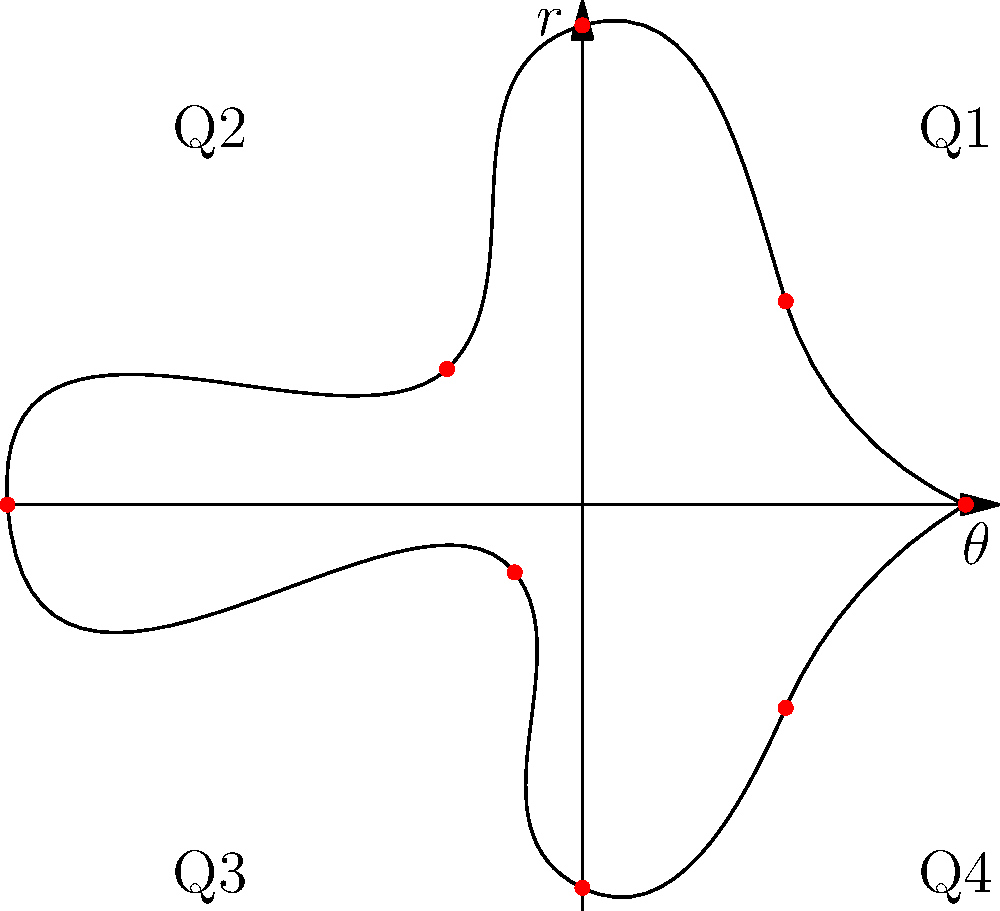As a business school student, you're analyzing quarterly economic trends for Brown Industries. The polar graph represents the company's revenue over two years, where the radius ($r$) indicates revenue in millions, and the angle ($\theta$) represents quarters. If Q1 of the first year starts at $\theta = 0$, what's the total revenue change from Q3 of the first year to Q3 of the second year? Let's approach this step-by-step:

1) First, we need to identify the points representing Q3 of the first and second years.
   - Q3 of the first year: $\theta = \pi$ (3rd point on the circle)
   - Q3 of the second year: $\theta = 5\pi/4$ (6th point on the circle)

2) Now, let's read the $r$ values (revenue in millions) for these points:
   - Q3 of the first year: $r = 6$ million
   - Q3 of the second year: $r = 1$ million

3) To calculate the change in revenue, we subtract the earlier value from the later value:
   $\text{Change} = 1 - 6 = -5$ million

4) The negative value indicates a decrease in revenue.

Therefore, the total revenue change from Q3 of the first year to Q3 of the second year is a decrease of $5 million.
Answer: $-5$ million 